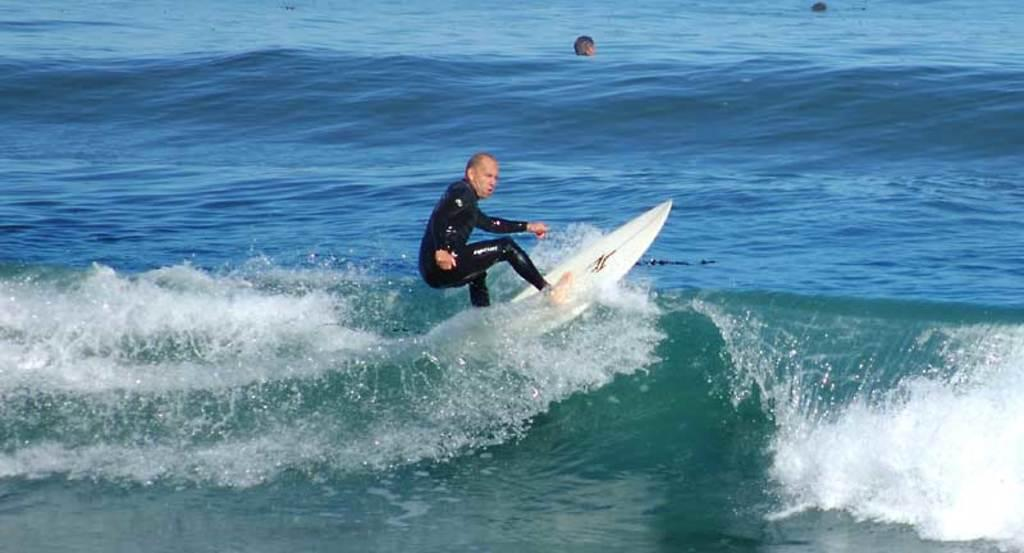What is the person in the image doing? There is a person on a surfboard in the image. What can be seen in the water around the person? Waves are visible in the water. Is there anyone else in the water besides the person on the surfboard? Yes, there is a person in the water. What is the black object on the water's surface? There appears to be a black object on the water's surface. What discovery was made by the person on the surfboard in the image? There is no indication of a discovery being made in the image; the person is simply surfing on a surfboard. How does the person on the surfboard cough in the image? There is no coughing depicted in the image; the person is focused on surfing. 